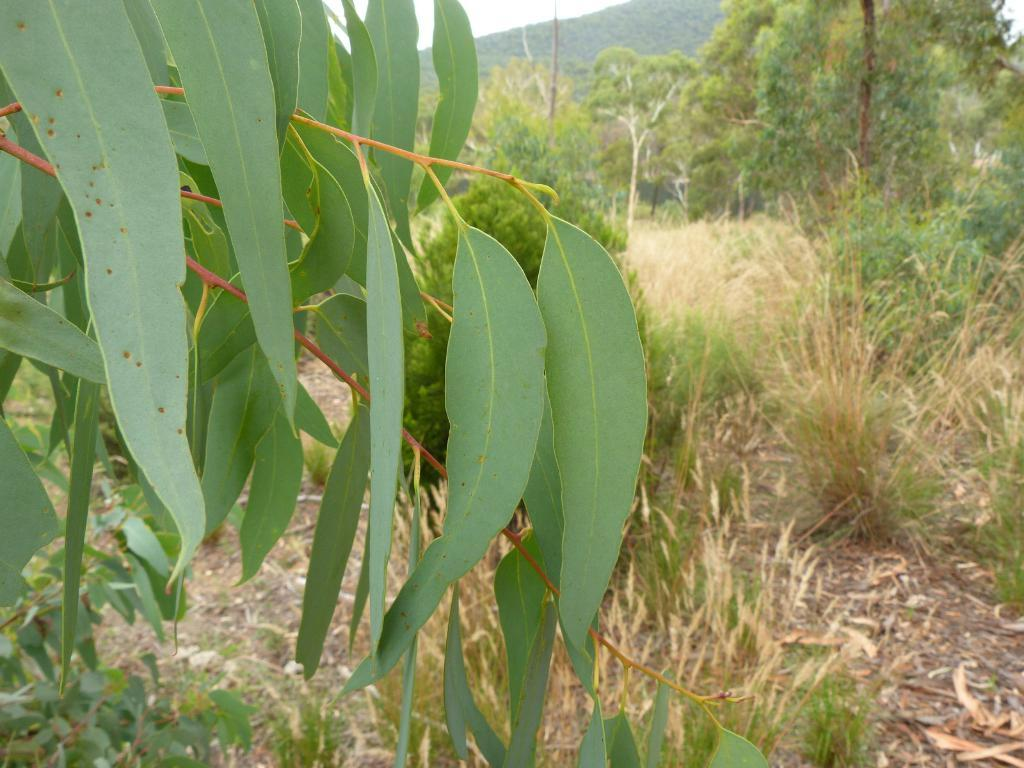What is located in the foreground of the image? There is a branch of a tree in the foreground of the image. What type of vegetation can be seen in the image? There are trees visible in the image. What natural feature can be seen in the image? There is a kill (possibly a reference to a small stream or river) visible in the image. What type of ground cover is present in the image? Grass is present in the image. How many jellyfish can be seen swimming in the kill in the image? There are no jellyfish visible in the image; it features a branch of a tree, trees, a kill, and grass. What impulse might have led to the creation of the kill in the image? The image does not provide information about the creation of the kill or any related impulses. 